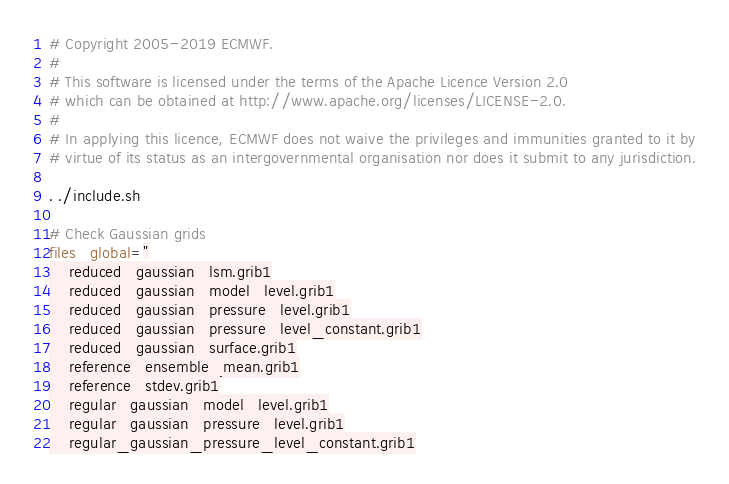Convert code to text. <code><loc_0><loc_0><loc_500><loc_500><_Bash_># Copyright 2005-2019 ECMWF.
#
# This software is licensed under the terms of the Apache Licence Version 2.0
# which can be obtained at http://www.apache.org/licenses/LICENSE-2.0.
#
# In applying this licence, ECMWF does not waive the privileges and immunities granted to it by
# virtue of its status as an intergovernmental organisation nor does it submit to any jurisdiction.

. ./include.sh

# Check Gaussian grids
files_global="
    reduced_gaussian_lsm.grib1
    reduced_gaussian_model_level.grib1
    reduced_gaussian_pressure_level.grib1
    reduced_gaussian_pressure_level_constant.grib1
    reduced_gaussian_surface.grib1
    reference_ensemble_mean.grib1
    reference_stdev.grib1
    regular_gaussian_model_level.grib1
    regular_gaussian_pressure_level.grib1
    regular_gaussian_pressure_level_constant.grib1</code> 